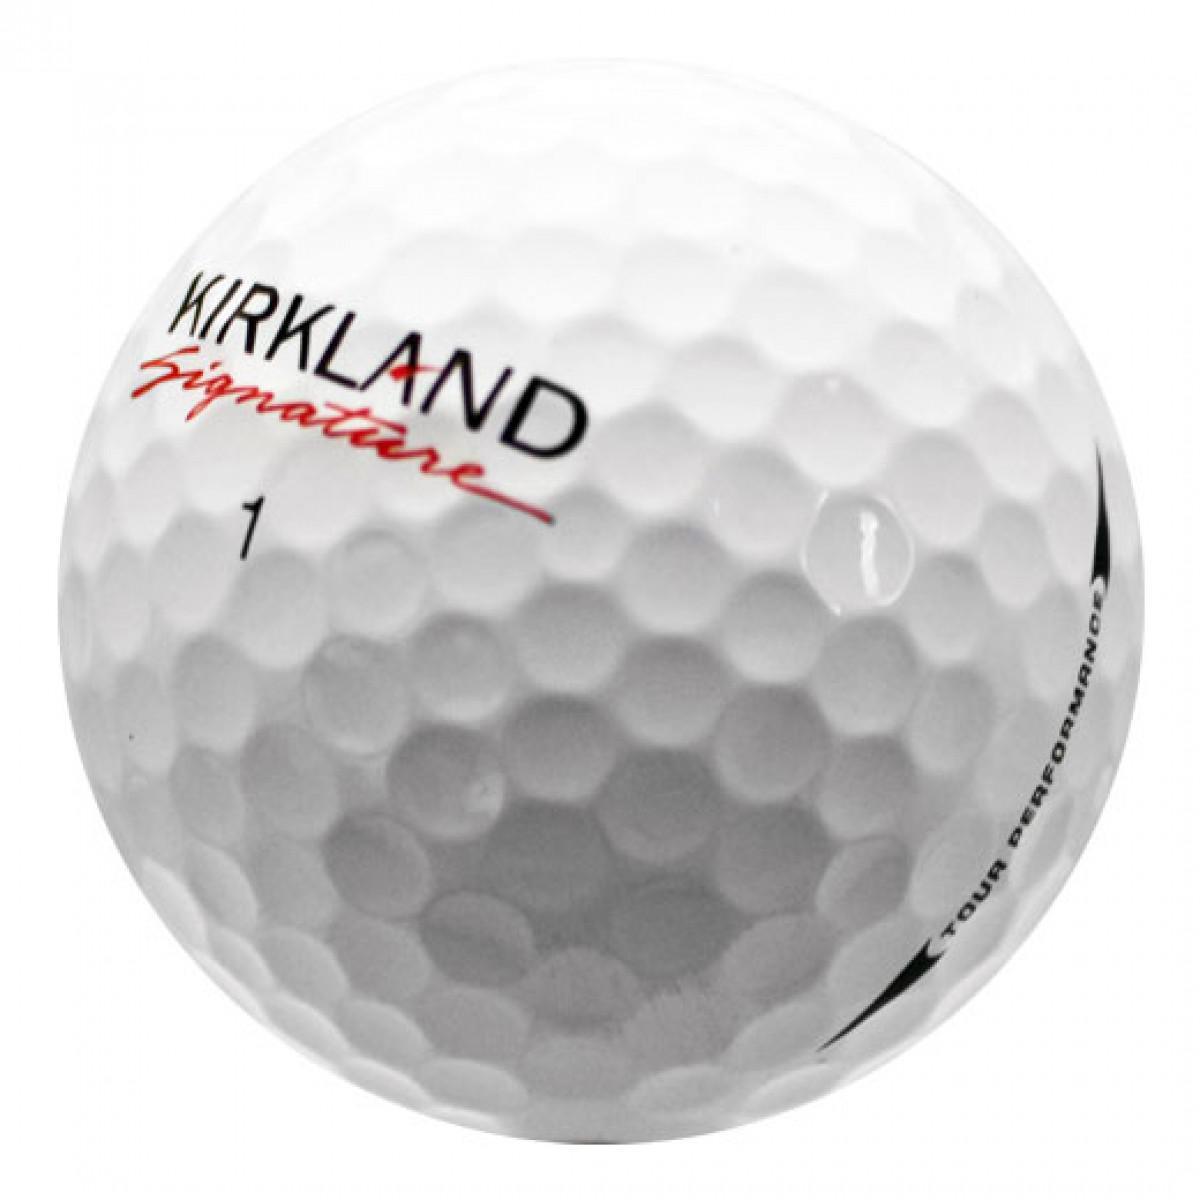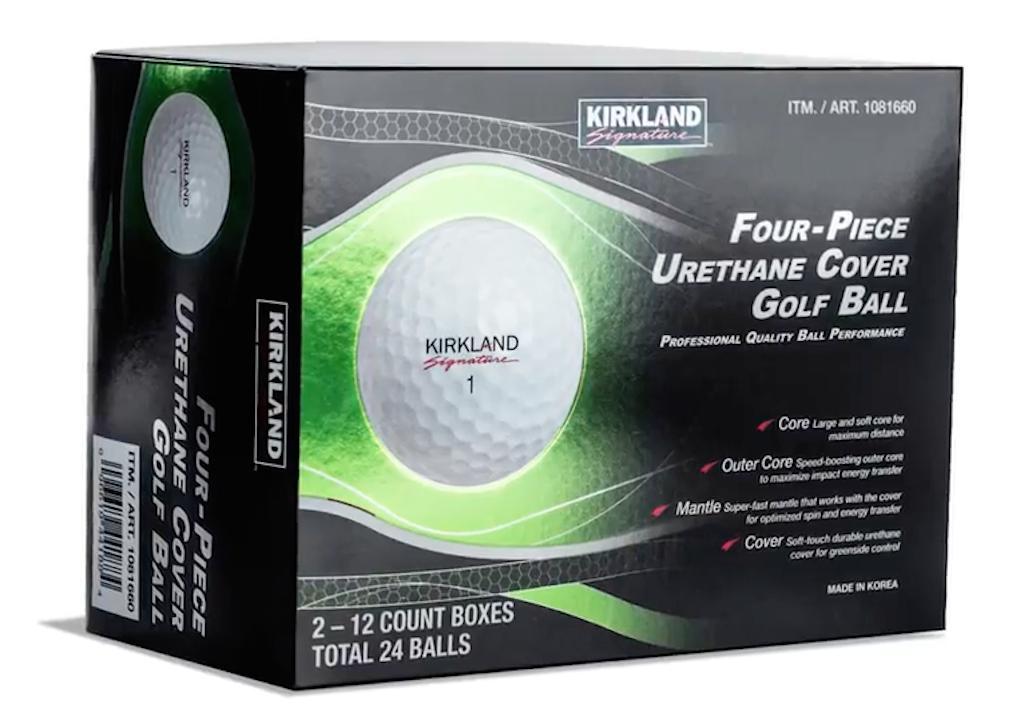The first image is the image on the left, the second image is the image on the right. Evaluate the accuracy of this statement regarding the images: "There are three golf balls". Is it true? Answer yes or no. No. 